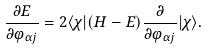Convert formula to latex. <formula><loc_0><loc_0><loc_500><loc_500>\frac { \partial E } { \partial \varphi _ { \alpha j } } = 2 \langle \chi | ( H - E ) \frac { \partial } { \partial \varphi _ { \alpha j } } | \chi \rangle .</formula> 